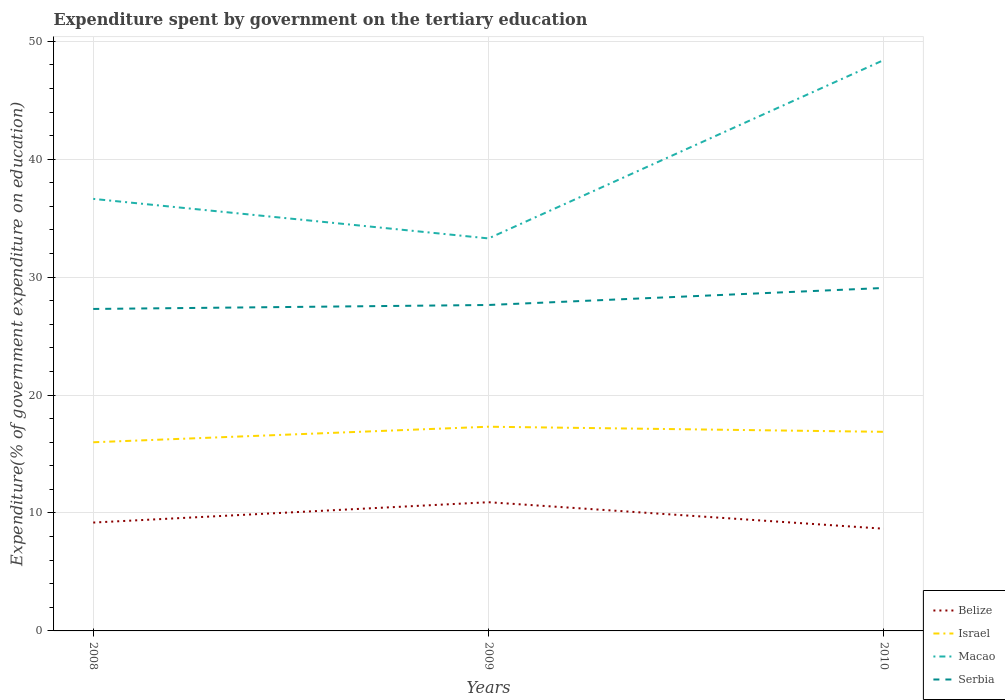Is the number of lines equal to the number of legend labels?
Your response must be concise. Yes. Across all years, what is the maximum expenditure spent by government on the tertiary education in Belize?
Keep it short and to the point. 8.67. In which year was the expenditure spent by government on the tertiary education in Belize maximum?
Give a very brief answer. 2010. What is the total expenditure spent by government on the tertiary education in Israel in the graph?
Offer a terse response. 0.43. What is the difference between the highest and the second highest expenditure spent by government on the tertiary education in Serbia?
Offer a very short reply. 1.78. What is the difference between the highest and the lowest expenditure spent by government on the tertiary education in Israel?
Offer a very short reply. 2. Is the expenditure spent by government on the tertiary education in Serbia strictly greater than the expenditure spent by government on the tertiary education in Israel over the years?
Offer a terse response. No. How many years are there in the graph?
Provide a short and direct response. 3. What is the difference between two consecutive major ticks on the Y-axis?
Provide a short and direct response. 10. Are the values on the major ticks of Y-axis written in scientific E-notation?
Keep it short and to the point. No. Where does the legend appear in the graph?
Your answer should be compact. Bottom right. How many legend labels are there?
Keep it short and to the point. 4. What is the title of the graph?
Your answer should be very brief. Expenditure spent by government on the tertiary education. Does "Antigua and Barbuda" appear as one of the legend labels in the graph?
Your answer should be very brief. No. What is the label or title of the X-axis?
Provide a short and direct response. Years. What is the label or title of the Y-axis?
Keep it short and to the point. Expenditure(% of government expenditure on education). What is the Expenditure(% of government expenditure on education) in Belize in 2008?
Offer a very short reply. 9.19. What is the Expenditure(% of government expenditure on education) of Israel in 2008?
Offer a very short reply. 16. What is the Expenditure(% of government expenditure on education) of Macao in 2008?
Your answer should be very brief. 36.64. What is the Expenditure(% of government expenditure on education) in Serbia in 2008?
Give a very brief answer. 27.3. What is the Expenditure(% of government expenditure on education) of Belize in 2009?
Your answer should be very brief. 10.91. What is the Expenditure(% of government expenditure on education) in Israel in 2009?
Offer a terse response. 17.32. What is the Expenditure(% of government expenditure on education) of Macao in 2009?
Offer a very short reply. 33.28. What is the Expenditure(% of government expenditure on education) of Serbia in 2009?
Your answer should be compact. 27.64. What is the Expenditure(% of government expenditure on education) in Belize in 2010?
Your answer should be very brief. 8.67. What is the Expenditure(% of government expenditure on education) in Israel in 2010?
Offer a very short reply. 16.88. What is the Expenditure(% of government expenditure on education) in Macao in 2010?
Offer a very short reply. 48.41. What is the Expenditure(% of government expenditure on education) in Serbia in 2010?
Make the answer very short. 29.08. Across all years, what is the maximum Expenditure(% of government expenditure on education) in Belize?
Keep it short and to the point. 10.91. Across all years, what is the maximum Expenditure(% of government expenditure on education) of Israel?
Make the answer very short. 17.32. Across all years, what is the maximum Expenditure(% of government expenditure on education) of Macao?
Offer a very short reply. 48.41. Across all years, what is the maximum Expenditure(% of government expenditure on education) of Serbia?
Make the answer very short. 29.08. Across all years, what is the minimum Expenditure(% of government expenditure on education) of Belize?
Give a very brief answer. 8.67. Across all years, what is the minimum Expenditure(% of government expenditure on education) in Israel?
Your response must be concise. 16. Across all years, what is the minimum Expenditure(% of government expenditure on education) of Macao?
Your answer should be very brief. 33.28. Across all years, what is the minimum Expenditure(% of government expenditure on education) in Serbia?
Your response must be concise. 27.3. What is the total Expenditure(% of government expenditure on education) of Belize in the graph?
Provide a succinct answer. 28.77. What is the total Expenditure(% of government expenditure on education) in Israel in the graph?
Ensure brevity in your answer.  50.2. What is the total Expenditure(% of government expenditure on education) in Macao in the graph?
Keep it short and to the point. 118.33. What is the total Expenditure(% of government expenditure on education) of Serbia in the graph?
Offer a very short reply. 84.02. What is the difference between the Expenditure(% of government expenditure on education) in Belize in 2008 and that in 2009?
Ensure brevity in your answer.  -1.72. What is the difference between the Expenditure(% of government expenditure on education) of Israel in 2008 and that in 2009?
Your response must be concise. -1.32. What is the difference between the Expenditure(% of government expenditure on education) of Macao in 2008 and that in 2009?
Make the answer very short. 3.35. What is the difference between the Expenditure(% of government expenditure on education) of Serbia in 2008 and that in 2009?
Your answer should be compact. -0.34. What is the difference between the Expenditure(% of government expenditure on education) in Belize in 2008 and that in 2010?
Offer a terse response. 0.52. What is the difference between the Expenditure(% of government expenditure on education) of Israel in 2008 and that in 2010?
Provide a short and direct response. -0.89. What is the difference between the Expenditure(% of government expenditure on education) in Macao in 2008 and that in 2010?
Keep it short and to the point. -11.78. What is the difference between the Expenditure(% of government expenditure on education) in Serbia in 2008 and that in 2010?
Offer a very short reply. -1.78. What is the difference between the Expenditure(% of government expenditure on education) of Belize in 2009 and that in 2010?
Offer a terse response. 2.25. What is the difference between the Expenditure(% of government expenditure on education) in Israel in 2009 and that in 2010?
Your answer should be compact. 0.43. What is the difference between the Expenditure(% of government expenditure on education) in Macao in 2009 and that in 2010?
Your answer should be compact. -15.13. What is the difference between the Expenditure(% of government expenditure on education) of Serbia in 2009 and that in 2010?
Ensure brevity in your answer.  -1.44. What is the difference between the Expenditure(% of government expenditure on education) in Belize in 2008 and the Expenditure(% of government expenditure on education) in Israel in 2009?
Your answer should be very brief. -8.13. What is the difference between the Expenditure(% of government expenditure on education) of Belize in 2008 and the Expenditure(% of government expenditure on education) of Macao in 2009?
Keep it short and to the point. -24.09. What is the difference between the Expenditure(% of government expenditure on education) in Belize in 2008 and the Expenditure(% of government expenditure on education) in Serbia in 2009?
Your answer should be very brief. -18.45. What is the difference between the Expenditure(% of government expenditure on education) in Israel in 2008 and the Expenditure(% of government expenditure on education) in Macao in 2009?
Ensure brevity in your answer.  -17.29. What is the difference between the Expenditure(% of government expenditure on education) in Israel in 2008 and the Expenditure(% of government expenditure on education) in Serbia in 2009?
Your response must be concise. -11.64. What is the difference between the Expenditure(% of government expenditure on education) of Macao in 2008 and the Expenditure(% of government expenditure on education) of Serbia in 2009?
Provide a succinct answer. 9. What is the difference between the Expenditure(% of government expenditure on education) in Belize in 2008 and the Expenditure(% of government expenditure on education) in Israel in 2010?
Provide a succinct answer. -7.69. What is the difference between the Expenditure(% of government expenditure on education) in Belize in 2008 and the Expenditure(% of government expenditure on education) in Macao in 2010?
Ensure brevity in your answer.  -39.22. What is the difference between the Expenditure(% of government expenditure on education) of Belize in 2008 and the Expenditure(% of government expenditure on education) of Serbia in 2010?
Your answer should be compact. -19.89. What is the difference between the Expenditure(% of government expenditure on education) in Israel in 2008 and the Expenditure(% of government expenditure on education) in Macao in 2010?
Your answer should be compact. -32.41. What is the difference between the Expenditure(% of government expenditure on education) of Israel in 2008 and the Expenditure(% of government expenditure on education) of Serbia in 2010?
Offer a very short reply. -13.09. What is the difference between the Expenditure(% of government expenditure on education) of Macao in 2008 and the Expenditure(% of government expenditure on education) of Serbia in 2010?
Make the answer very short. 7.55. What is the difference between the Expenditure(% of government expenditure on education) in Belize in 2009 and the Expenditure(% of government expenditure on education) in Israel in 2010?
Your response must be concise. -5.97. What is the difference between the Expenditure(% of government expenditure on education) of Belize in 2009 and the Expenditure(% of government expenditure on education) of Macao in 2010?
Offer a very short reply. -37.5. What is the difference between the Expenditure(% of government expenditure on education) of Belize in 2009 and the Expenditure(% of government expenditure on education) of Serbia in 2010?
Offer a terse response. -18.17. What is the difference between the Expenditure(% of government expenditure on education) of Israel in 2009 and the Expenditure(% of government expenditure on education) of Macao in 2010?
Keep it short and to the point. -31.1. What is the difference between the Expenditure(% of government expenditure on education) in Israel in 2009 and the Expenditure(% of government expenditure on education) in Serbia in 2010?
Offer a terse response. -11.77. What is the difference between the Expenditure(% of government expenditure on education) of Macao in 2009 and the Expenditure(% of government expenditure on education) of Serbia in 2010?
Your answer should be very brief. 4.2. What is the average Expenditure(% of government expenditure on education) of Belize per year?
Keep it short and to the point. 9.59. What is the average Expenditure(% of government expenditure on education) in Israel per year?
Your response must be concise. 16.73. What is the average Expenditure(% of government expenditure on education) in Macao per year?
Give a very brief answer. 39.44. What is the average Expenditure(% of government expenditure on education) in Serbia per year?
Offer a terse response. 28.01. In the year 2008, what is the difference between the Expenditure(% of government expenditure on education) of Belize and Expenditure(% of government expenditure on education) of Israel?
Keep it short and to the point. -6.81. In the year 2008, what is the difference between the Expenditure(% of government expenditure on education) of Belize and Expenditure(% of government expenditure on education) of Macao?
Ensure brevity in your answer.  -27.45. In the year 2008, what is the difference between the Expenditure(% of government expenditure on education) in Belize and Expenditure(% of government expenditure on education) in Serbia?
Provide a short and direct response. -18.11. In the year 2008, what is the difference between the Expenditure(% of government expenditure on education) of Israel and Expenditure(% of government expenditure on education) of Macao?
Offer a terse response. -20.64. In the year 2008, what is the difference between the Expenditure(% of government expenditure on education) of Israel and Expenditure(% of government expenditure on education) of Serbia?
Offer a very short reply. -11.3. In the year 2008, what is the difference between the Expenditure(% of government expenditure on education) in Macao and Expenditure(% of government expenditure on education) in Serbia?
Keep it short and to the point. 9.33. In the year 2009, what is the difference between the Expenditure(% of government expenditure on education) in Belize and Expenditure(% of government expenditure on education) in Israel?
Provide a short and direct response. -6.4. In the year 2009, what is the difference between the Expenditure(% of government expenditure on education) of Belize and Expenditure(% of government expenditure on education) of Macao?
Your answer should be very brief. -22.37. In the year 2009, what is the difference between the Expenditure(% of government expenditure on education) of Belize and Expenditure(% of government expenditure on education) of Serbia?
Provide a short and direct response. -16.72. In the year 2009, what is the difference between the Expenditure(% of government expenditure on education) in Israel and Expenditure(% of government expenditure on education) in Macao?
Your answer should be compact. -15.97. In the year 2009, what is the difference between the Expenditure(% of government expenditure on education) in Israel and Expenditure(% of government expenditure on education) in Serbia?
Your answer should be compact. -10.32. In the year 2009, what is the difference between the Expenditure(% of government expenditure on education) of Macao and Expenditure(% of government expenditure on education) of Serbia?
Your answer should be very brief. 5.64. In the year 2010, what is the difference between the Expenditure(% of government expenditure on education) in Belize and Expenditure(% of government expenditure on education) in Israel?
Your answer should be very brief. -8.22. In the year 2010, what is the difference between the Expenditure(% of government expenditure on education) in Belize and Expenditure(% of government expenditure on education) in Macao?
Give a very brief answer. -39.75. In the year 2010, what is the difference between the Expenditure(% of government expenditure on education) of Belize and Expenditure(% of government expenditure on education) of Serbia?
Your response must be concise. -20.42. In the year 2010, what is the difference between the Expenditure(% of government expenditure on education) in Israel and Expenditure(% of government expenditure on education) in Macao?
Offer a terse response. -31.53. In the year 2010, what is the difference between the Expenditure(% of government expenditure on education) of Israel and Expenditure(% of government expenditure on education) of Serbia?
Provide a short and direct response. -12.2. In the year 2010, what is the difference between the Expenditure(% of government expenditure on education) in Macao and Expenditure(% of government expenditure on education) in Serbia?
Your answer should be compact. 19.33. What is the ratio of the Expenditure(% of government expenditure on education) of Belize in 2008 to that in 2009?
Make the answer very short. 0.84. What is the ratio of the Expenditure(% of government expenditure on education) in Israel in 2008 to that in 2009?
Keep it short and to the point. 0.92. What is the ratio of the Expenditure(% of government expenditure on education) in Macao in 2008 to that in 2009?
Provide a succinct answer. 1.1. What is the ratio of the Expenditure(% of government expenditure on education) of Serbia in 2008 to that in 2009?
Your response must be concise. 0.99. What is the ratio of the Expenditure(% of government expenditure on education) of Belize in 2008 to that in 2010?
Your answer should be very brief. 1.06. What is the ratio of the Expenditure(% of government expenditure on education) of Israel in 2008 to that in 2010?
Offer a terse response. 0.95. What is the ratio of the Expenditure(% of government expenditure on education) of Macao in 2008 to that in 2010?
Ensure brevity in your answer.  0.76. What is the ratio of the Expenditure(% of government expenditure on education) in Serbia in 2008 to that in 2010?
Ensure brevity in your answer.  0.94. What is the ratio of the Expenditure(% of government expenditure on education) of Belize in 2009 to that in 2010?
Offer a terse response. 1.26. What is the ratio of the Expenditure(% of government expenditure on education) of Israel in 2009 to that in 2010?
Your answer should be very brief. 1.03. What is the ratio of the Expenditure(% of government expenditure on education) in Macao in 2009 to that in 2010?
Your answer should be compact. 0.69. What is the ratio of the Expenditure(% of government expenditure on education) in Serbia in 2009 to that in 2010?
Your answer should be very brief. 0.95. What is the difference between the highest and the second highest Expenditure(% of government expenditure on education) in Belize?
Provide a short and direct response. 1.72. What is the difference between the highest and the second highest Expenditure(% of government expenditure on education) in Israel?
Keep it short and to the point. 0.43. What is the difference between the highest and the second highest Expenditure(% of government expenditure on education) of Macao?
Give a very brief answer. 11.78. What is the difference between the highest and the second highest Expenditure(% of government expenditure on education) in Serbia?
Ensure brevity in your answer.  1.44. What is the difference between the highest and the lowest Expenditure(% of government expenditure on education) of Belize?
Make the answer very short. 2.25. What is the difference between the highest and the lowest Expenditure(% of government expenditure on education) of Israel?
Offer a terse response. 1.32. What is the difference between the highest and the lowest Expenditure(% of government expenditure on education) of Macao?
Your answer should be compact. 15.13. What is the difference between the highest and the lowest Expenditure(% of government expenditure on education) of Serbia?
Ensure brevity in your answer.  1.78. 